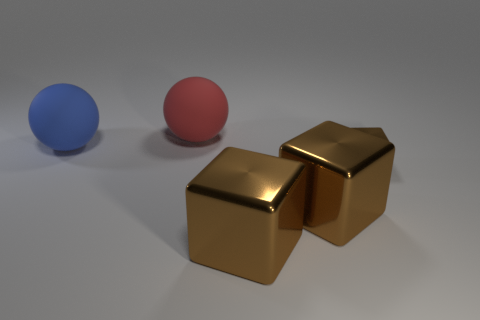Add 3 rubber blocks. How many objects exist? 8 Subtract all balls. How many objects are left? 3 Subtract 0 brown cylinders. How many objects are left? 5 Subtract all brown cubes. Subtract all tiny shiny things. How many objects are left? 1 Add 5 red things. How many red things are left? 6 Add 3 tiny brown shiny objects. How many tiny brown shiny objects exist? 4 